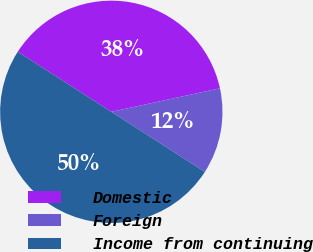<chart> <loc_0><loc_0><loc_500><loc_500><pie_chart><fcel>Domestic<fcel>Foreign<fcel>Income from continuing<nl><fcel>37.51%<fcel>12.49%<fcel>50.0%<nl></chart> 